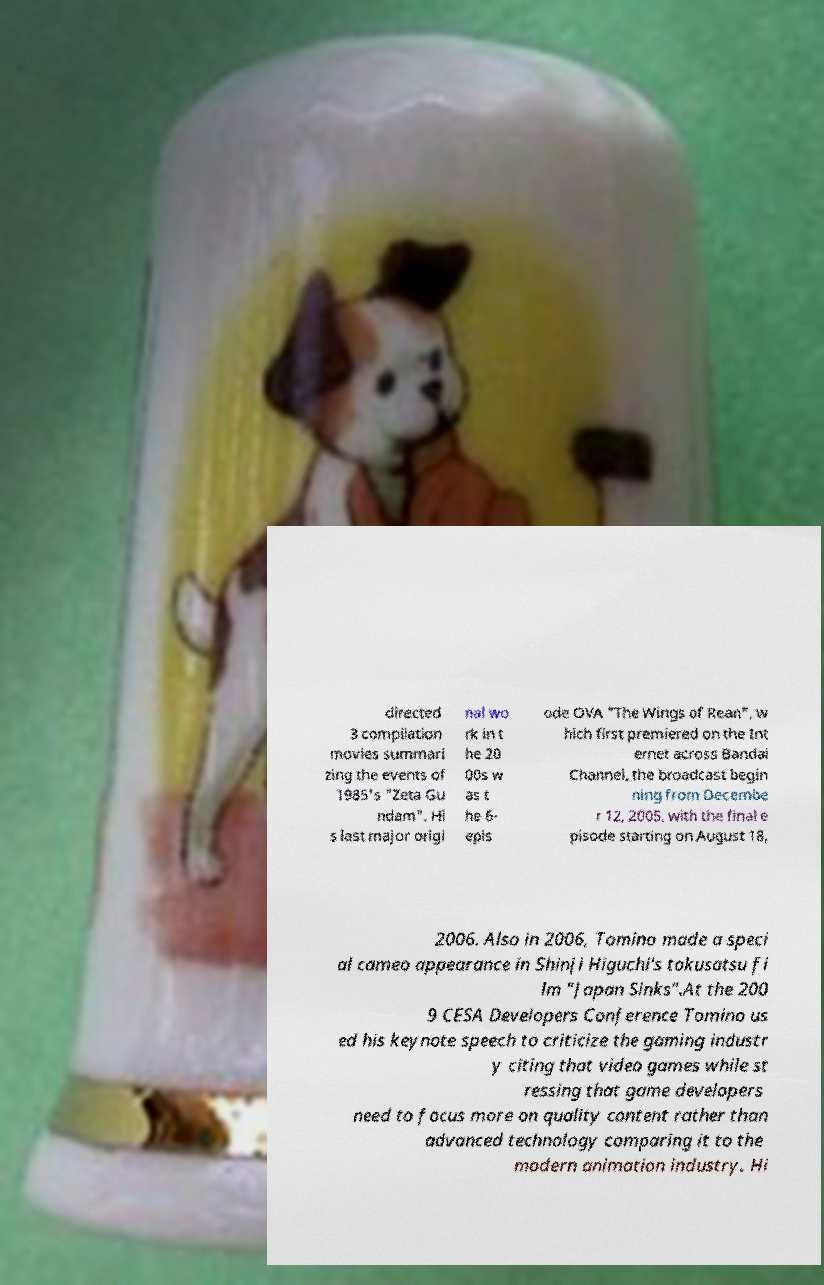Please read and relay the text visible in this image. What does it say? directed 3 compilation movies summari zing the events of 1985's "Zeta Gu ndam". Hi s last major origi nal wo rk in t he 20 00s w as t he 6- epis ode OVA "The Wings of Rean", w hich first premiered on the Int ernet across Bandai Channel, the broadcast begin ning from Decembe r 12, 2005, with the final e pisode starting on August 18, 2006. Also in 2006, Tomino made a speci al cameo appearance in Shinji Higuchi's tokusatsu fi lm "Japan Sinks".At the 200 9 CESA Developers Conference Tomino us ed his keynote speech to criticize the gaming industr y citing that video games while st ressing that game developers need to focus more on quality content rather than advanced technology comparing it to the modern animation industry. Hi 